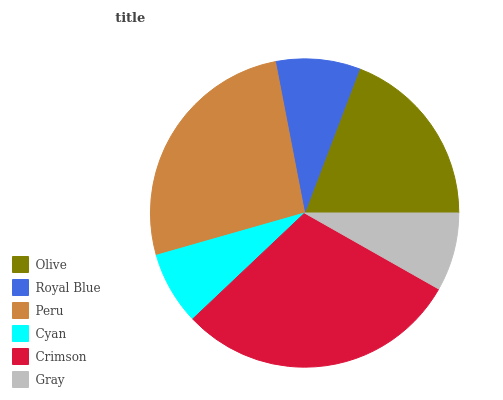Is Cyan the minimum?
Answer yes or no. Yes. Is Crimson the maximum?
Answer yes or no. Yes. Is Royal Blue the minimum?
Answer yes or no. No. Is Royal Blue the maximum?
Answer yes or no. No. Is Olive greater than Royal Blue?
Answer yes or no. Yes. Is Royal Blue less than Olive?
Answer yes or no. Yes. Is Royal Blue greater than Olive?
Answer yes or no. No. Is Olive less than Royal Blue?
Answer yes or no. No. Is Olive the high median?
Answer yes or no. Yes. Is Royal Blue the low median?
Answer yes or no. Yes. Is Peru the high median?
Answer yes or no. No. Is Olive the low median?
Answer yes or no. No. 